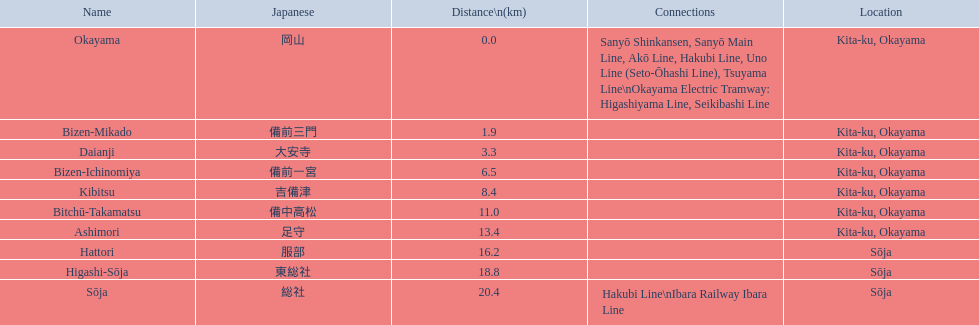Which individuals make up the kibi line? Okayama, Bizen-Mikado, Daianji, Bizen-Ichinomiya, Kibitsu, Bitchū-Takamatsu, Ashimori, Hattori, Higashi-Sōja, Sōja. From these, which have a distance exceeding 1 km? Bizen-Mikado, Daianji, Bizen-Ichinomiya, Kibitsu, Bitchū-Takamatsu, Ashimori, Hattori, Higashi-Sōja, Sōja. Which are within 2 km? Okayama, Bizen-Mikado. And which are located at a distance from 1 km to 2 km? Bizen-Mikado. 